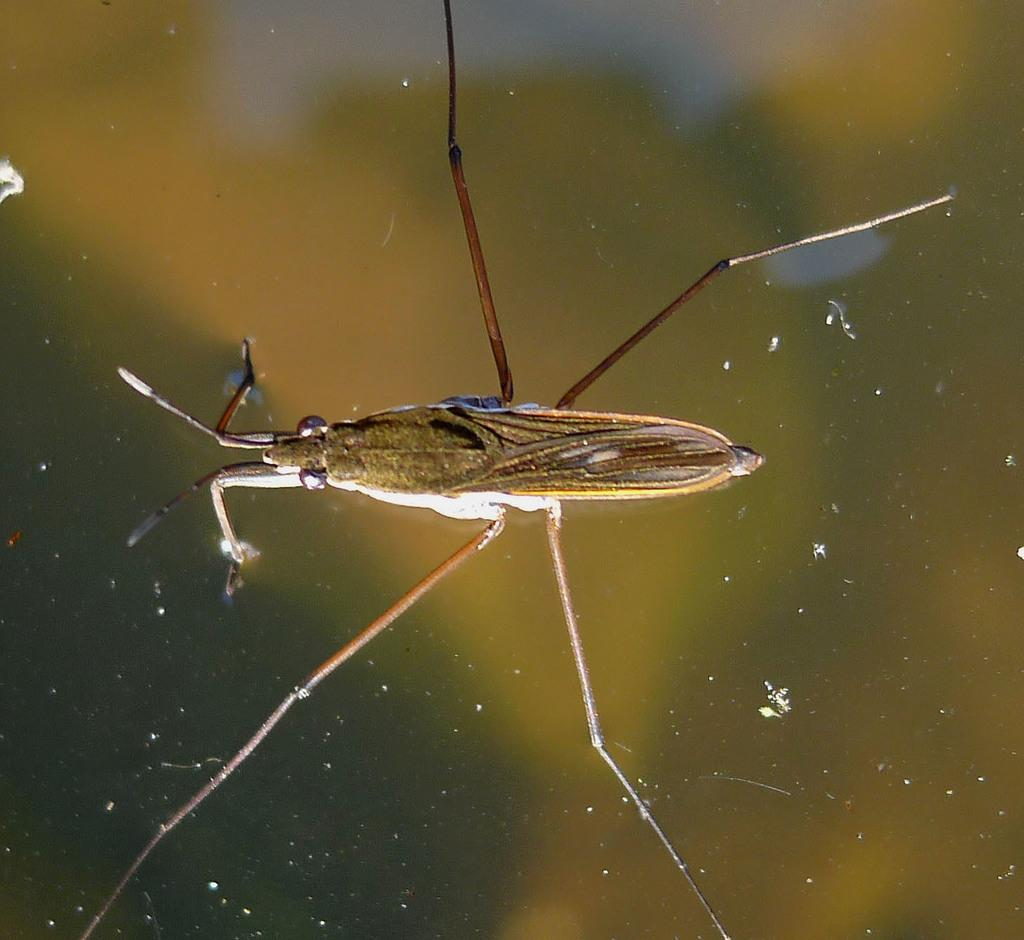What type of creature is in the picture? There is an insect in the picture. How many legs does the insect have? The insect has four legs. What features can be seen on the insect's head? The insect has eyes and antenna. Can the insect fly? Yes, the insect has wings. Where is the insect located in the image? The insect is on the water. What type of fan can be seen in the image? There is no fan present in the image; it features an insect on the water. Can you tell me how many notebooks are visible in the image? There are no notebooks present in the image. 